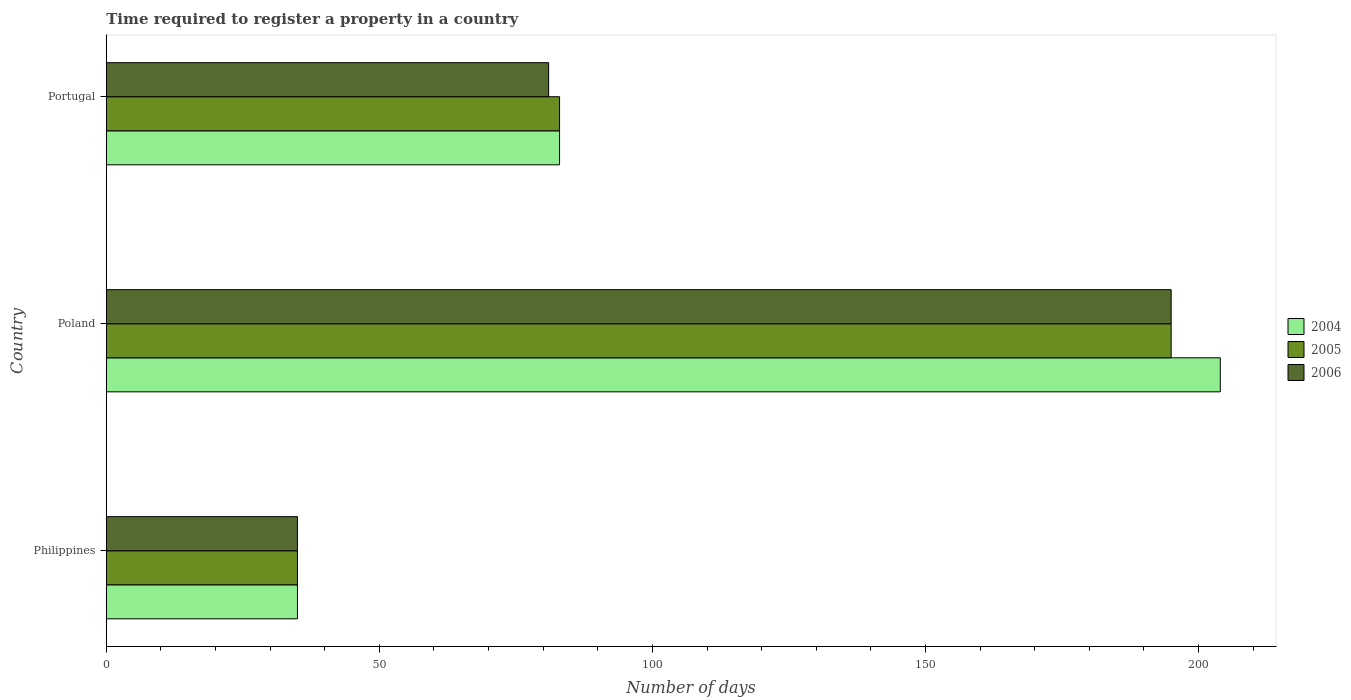Are the number of bars on each tick of the Y-axis equal?
Offer a very short reply. Yes. How many bars are there on the 3rd tick from the top?
Give a very brief answer. 3. In how many cases, is the number of bars for a given country not equal to the number of legend labels?
Give a very brief answer. 0. What is the number of days required to register a property in 2005 in Poland?
Provide a short and direct response. 195. Across all countries, what is the maximum number of days required to register a property in 2006?
Provide a short and direct response. 195. Across all countries, what is the minimum number of days required to register a property in 2006?
Ensure brevity in your answer.  35. In which country was the number of days required to register a property in 2004 maximum?
Provide a short and direct response. Poland. In which country was the number of days required to register a property in 2004 minimum?
Make the answer very short. Philippines. What is the total number of days required to register a property in 2005 in the graph?
Ensure brevity in your answer.  313. What is the difference between the number of days required to register a property in 2006 in Philippines and that in Portugal?
Your answer should be very brief. -46. What is the difference between the number of days required to register a property in 2006 in Poland and the number of days required to register a property in 2004 in Philippines?
Provide a succinct answer. 160. What is the average number of days required to register a property in 2004 per country?
Ensure brevity in your answer.  107.33. What is the difference between the number of days required to register a property in 2005 and number of days required to register a property in 2006 in Portugal?
Give a very brief answer. 2. In how many countries, is the number of days required to register a property in 2004 greater than 10 days?
Make the answer very short. 3. What is the ratio of the number of days required to register a property in 2006 in Philippines to that in Portugal?
Make the answer very short. 0.43. Is the number of days required to register a property in 2005 in Poland less than that in Portugal?
Your response must be concise. No. Is the difference between the number of days required to register a property in 2005 in Philippines and Portugal greater than the difference between the number of days required to register a property in 2006 in Philippines and Portugal?
Your answer should be very brief. No. What is the difference between the highest and the second highest number of days required to register a property in 2006?
Offer a terse response. 114. What is the difference between the highest and the lowest number of days required to register a property in 2006?
Provide a short and direct response. 160. In how many countries, is the number of days required to register a property in 2005 greater than the average number of days required to register a property in 2005 taken over all countries?
Offer a terse response. 1. What does the 1st bar from the bottom in Philippines represents?
Your answer should be compact. 2004. How many bars are there?
Offer a very short reply. 9. Are all the bars in the graph horizontal?
Provide a succinct answer. Yes. How many countries are there in the graph?
Provide a succinct answer. 3. Are the values on the major ticks of X-axis written in scientific E-notation?
Ensure brevity in your answer.  No. Does the graph contain any zero values?
Make the answer very short. No. Does the graph contain grids?
Give a very brief answer. No. Where does the legend appear in the graph?
Your answer should be very brief. Center right. What is the title of the graph?
Keep it short and to the point. Time required to register a property in a country. Does "1993" appear as one of the legend labels in the graph?
Provide a succinct answer. No. What is the label or title of the X-axis?
Your response must be concise. Number of days. What is the label or title of the Y-axis?
Provide a succinct answer. Country. What is the Number of days of 2005 in Philippines?
Offer a very short reply. 35. What is the Number of days of 2006 in Philippines?
Offer a very short reply. 35. What is the Number of days of 2004 in Poland?
Your response must be concise. 204. What is the Number of days in 2005 in Poland?
Your answer should be compact. 195. What is the Number of days of 2006 in Poland?
Offer a very short reply. 195. What is the Number of days of 2004 in Portugal?
Provide a short and direct response. 83. What is the Number of days in 2005 in Portugal?
Your response must be concise. 83. What is the Number of days of 2006 in Portugal?
Keep it short and to the point. 81. Across all countries, what is the maximum Number of days of 2004?
Make the answer very short. 204. Across all countries, what is the maximum Number of days of 2005?
Provide a short and direct response. 195. Across all countries, what is the maximum Number of days in 2006?
Your response must be concise. 195. Across all countries, what is the minimum Number of days of 2006?
Provide a succinct answer. 35. What is the total Number of days in 2004 in the graph?
Your answer should be very brief. 322. What is the total Number of days in 2005 in the graph?
Ensure brevity in your answer.  313. What is the total Number of days of 2006 in the graph?
Keep it short and to the point. 311. What is the difference between the Number of days in 2004 in Philippines and that in Poland?
Your answer should be very brief. -169. What is the difference between the Number of days of 2005 in Philippines and that in Poland?
Ensure brevity in your answer.  -160. What is the difference between the Number of days in 2006 in Philippines and that in Poland?
Your answer should be compact. -160. What is the difference between the Number of days of 2004 in Philippines and that in Portugal?
Offer a terse response. -48. What is the difference between the Number of days in 2005 in Philippines and that in Portugal?
Your response must be concise. -48. What is the difference between the Number of days of 2006 in Philippines and that in Portugal?
Your answer should be very brief. -46. What is the difference between the Number of days of 2004 in Poland and that in Portugal?
Ensure brevity in your answer.  121. What is the difference between the Number of days of 2005 in Poland and that in Portugal?
Ensure brevity in your answer.  112. What is the difference between the Number of days in 2006 in Poland and that in Portugal?
Your response must be concise. 114. What is the difference between the Number of days of 2004 in Philippines and the Number of days of 2005 in Poland?
Offer a very short reply. -160. What is the difference between the Number of days of 2004 in Philippines and the Number of days of 2006 in Poland?
Your answer should be very brief. -160. What is the difference between the Number of days in 2005 in Philippines and the Number of days in 2006 in Poland?
Your answer should be compact. -160. What is the difference between the Number of days of 2004 in Philippines and the Number of days of 2005 in Portugal?
Make the answer very short. -48. What is the difference between the Number of days of 2004 in Philippines and the Number of days of 2006 in Portugal?
Make the answer very short. -46. What is the difference between the Number of days of 2005 in Philippines and the Number of days of 2006 in Portugal?
Ensure brevity in your answer.  -46. What is the difference between the Number of days of 2004 in Poland and the Number of days of 2005 in Portugal?
Provide a short and direct response. 121. What is the difference between the Number of days of 2004 in Poland and the Number of days of 2006 in Portugal?
Your answer should be very brief. 123. What is the difference between the Number of days of 2005 in Poland and the Number of days of 2006 in Portugal?
Keep it short and to the point. 114. What is the average Number of days of 2004 per country?
Offer a very short reply. 107.33. What is the average Number of days in 2005 per country?
Provide a succinct answer. 104.33. What is the average Number of days in 2006 per country?
Your response must be concise. 103.67. What is the difference between the Number of days in 2004 and Number of days in 2005 in Poland?
Offer a very short reply. 9. What is the difference between the Number of days in 2004 and Number of days in 2005 in Portugal?
Keep it short and to the point. 0. What is the difference between the Number of days of 2005 and Number of days of 2006 in Portugal?
Your answer should be compact. 2. What is the ratio of the Number of days in 2004 in Philippines to that in Poland?
Provide a short and direct response. 0.17. What is the ratio of the Number of days in 2005 in Philippines to that in Poland?
Offer a very short reply. 0.18. What is the ratio of the Number of days in 2006 in Philippines to that in Poland?
Give a very brief answer. 0.18. What is the ratio of the Number of days in 2004 in Philippines to that in Portugal?
Provide a succinct answer. 0.42. What is the ratio of the Number of days in 2005 in Philippines to that in Portugal?
Offer a terse response. 0.42. What is the ratio of the Number of days in 2006 in Philippines to that in Portugal?
Your response must be concise. 0.43. What is the ratio of the Number of days of 2004 in Poland to that in Portugal?
Offer a very short reply. 2.46. What is the ratio of the Number of days in 2005 in Poland to that in Portugal?
Your answer should be very brief. 2.35. What is the ratio of the Number of days in 2006 in Poland to that in Portugal?
Keep it short and to the point. 2.41. What is the difference between the highest and the second highest Number of days in 2004?
Offer a very short reply. 121. What is the difference between the highest and the second highest Number of days of 2005?
Your answer should be compact. 112. What is the difference between the highest and the second highest Number of days in 2006?
Make the answer very short. 114. What is the difference between the highest and the lowest Number of days in 2004?
Make the answer very short. 169. What is the difference between the highest and the lowest Number of days of 2005?
Your answer should be compact. 160. What is the difference between the highest and the lowest Number of days of 2006?
Your answer should be compact. 160. 